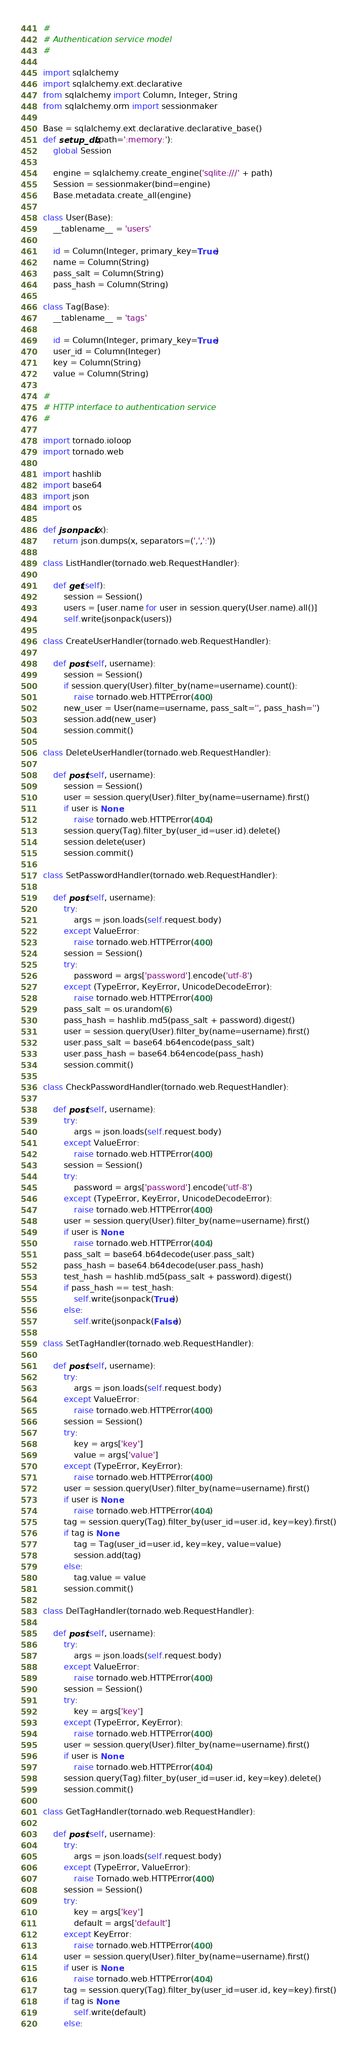<code> <loc_0><loc_0><loc_500><loc_500><_Python_>#
# Authentication service model
#

import sqlalchemy
import sqlalchemy.ext.declarative
from sqlalchemy import Column, Integer, String
from sqlalchemy.orm import sessionmaker

Base = sqlalchemy.ext.declarative.declarative_base()
def setup_db(path=':memory:'):
	global Session

	engine = sqlalchemy.create_engine('sqlite:///' + path)
	Session = sessionmaker(bind=engine)
	Base.metadata.create_all(engine)

class User(Base):
	__tablename__ = 'users'

	id = Column(Integer, primary_key=True)
	name = Column(String)
	pass_salt = Column(String)
	pass_hash = Column(String)

class Tag(Base):
	__tablename__ = 'tags'

	id = Column(Integer, primary_key=True)
	user_id = Column(Integer)
	key = Column(String)
	value = Column(String)

#
# HTTP interface to authentication service
#

import tornado.ioloop
import tornado.web

import hashlib
import base64
import json
import os

def jsonpack(x):
	return json.dumps(x, separators=(',',':'))

class ListHandler(tornado.web.RequestHandler):
	
	def get(self):
		session = Session()
		users = [user.name for user in session.query(User.name).all()]
		self.write(jsonpack(users))

class CreateUserHandler(tornado.web.RequestHandler):
	
	def post(self, username):
		session = Session()
		if session.query(User).filter_by(name=username).count():
			raise tornado.web.HTTPError(400)
		new_user = User(name=username, pass_salt='', pass_hash='')
		session.add(new_user)
		session.commit()

class DeleteUserHandler(tornado.web.RequestHandler):

	def post(self, username):
		session = Session()
		user = session.query(User).filter_by(name=username).first()
		if user is None:
			raise tornado.web.HTTPError(404)
		session.query(Tag).filter_by(user_id=user.id).delete()
		session.delete(user)
		session.commit()

class SetPasswordHandler(tornado.web.RequestHandler):
	
	def post(self, username):
		try:
			args = json.loads(self.request.body)
		except ValueError:
			raise tornado.web.HTTPError(400)
		session = Session()
		try:
			password = args['password'].encode('utf-8')
		except (TypeError, KeyError, UnicodeDecodeError):
			raise tornado.web.HTTPError(400)
		pass_salt = os.urandom(6)
		pass_hash = hashlib.md5(pass_salt + password).digest()
		user = session.query(User).filter_by(name=username).first()
		user.pass_salt = base64.b64encode(pass_salt)
		user.pass_hash = base64.b64encode(pass_hash)
		session.commit()

class CheckPasswordHandler(tornado.web.RequestHandler):
	
	def post(self, username):
		try:
			args = json.loads(self.request.body)
		except ValueError:
			raise tornado.web.HTTPError(400)
		session = Session()
		try:
			password = args['password'].encode('utf-8')
		except (TypeError, KeyError, UnicodeDecodeError):
			raise tornado.web.HTTPError(400)
		user = session.query(User).filter_by(name=username).first()
		if user is None:
			raise tornado.web.HTTPError(404)
		pass_salt = base64.b64decode(user.pass_salt)
		pass_hash = base64.b64decode(user.pass_hash)
		test_hash = hashlib.md5(pass_salt + password).digest()
		if pass_hash == test_hash:
			self.write(jsonpack(True))
		else:
			self.write(jsonpack(False))

class SetTagHandler(tornado.web.RequestHandler):

	def post(self, username):
		try:
			args = json.loads(self.request.body)
		except ValueError:
			raise tornado.web.HTTPError(400)
		session = Session()
		try:
			key = args['key']
			value = args['value'] 
		except (TypeError, KeyError):
			raise tornado.web.HTTPError(400)
		user = session.query(User).filter_by(name=username).first()
		if user is None:
			raise tornado.web.HTTPError(404)
		tag = session.query(Tag).filter_by(user_id=user.id, key=key).first()
		if tag is None:
			tag = Tag(user_id=user.id, key=key, value=value)
			session.add(tag)
		else:
			tag.value = value
		session.commit()

class DelTagHandler(tornado.web.RequestHandler):

	def post(self, username):
		try:
			args = json.loads(self.request.body)
		except ValueError:
			raise tornado.web.HTTPError(400)
		session = Session()
		try:
			key = args['key']
		except (TypeError, KeyError):
			raise tornado.web.HTTPError(400)
		user = session.query(User).filter_by(name=username).first()
		if user is None:
			raise tornado.web.HTTPError(404)
		session.query(Tag).filter_by(user_id=user.id, key=key).delete()
		session.commit()
	
class GetTagHandler(tornado.web.RequestHandler):
	
	def post(self, username):
		try:
			args = json.loads(self.request.body)
		except (TypeError, ValueError):
			raise Tornado.web.HTTPError(400)
		session = Session()
		try:
			key = args['key']
			default = args['default']
		except KeyError:
			raise tornado.web.HTTPError(400)
		user = session.query(User).filter_by(name=username).first()
		if user is None:
			raise tornado.web.HTTPError(404)
		tag = session.query(Tag).filter_by(user_id=user.id, key=key).first()
		if tag is None:
			self.write(default)
		else:</code> 